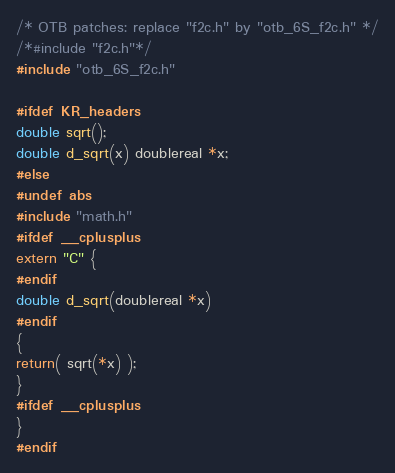Convert code to text. <code><loc_0><loc_0><loc_500><loc_500><_C_>
/* OTB patches: replace "f2c.h" by "otb_6S_f2c.h" */
/*#include "f2c.h"*/
#include "otb_6S_f2c.h"

#ifdef KR_headers
double sqrt();
double d_sqrt(x) doublereal *x;
#else
#undef abs
#include "math.h"
#ifdef __cplusplus
extern "C" {
#endif
double d_sqrt(doublereal *x)
#endif
{
return( sqrt(*x) );
}
#ifdef __cplusplus
}
#endif
</code> 